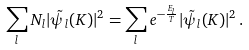Convert formula to latex. <formula><loc_0><loc_0><loc_500><loc_500>\sum _ { l } N _ { l } | \tilde { \psi } _ { l } ( { K } ) | ^ { 2 } = \sum _ { l } e ^ { - \frac { E _ { l } } { T } } | \tilde { \psi } _ { l } ( { K } ) | ^ { 2 } \, .</formula> 